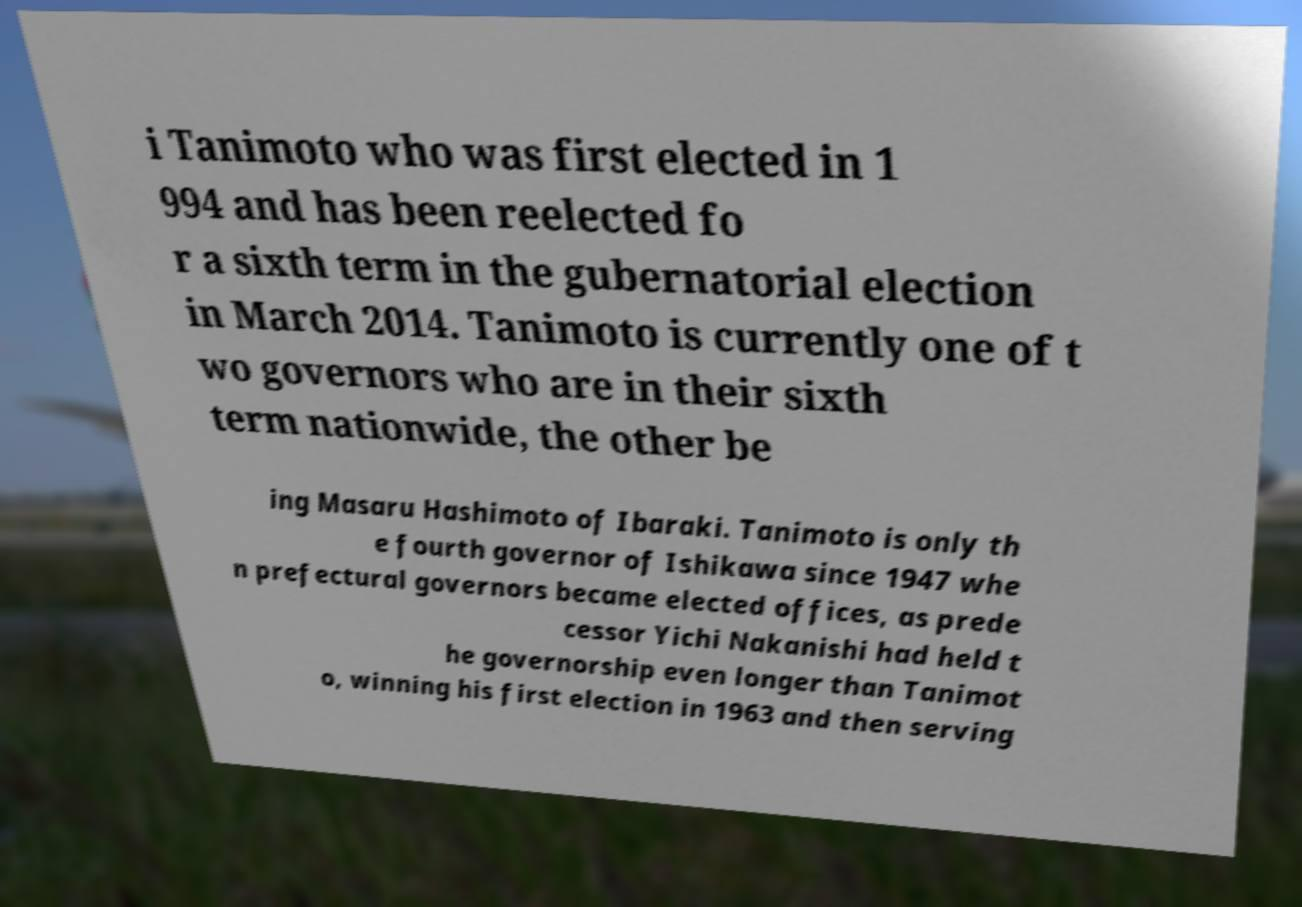I need the written content from this picture converted into text. Can you do that? i Tanimoto who was first elected in 1 994 and has been reelected fo r a sixth term in the gubernatorial election in March 2014. Tanimoto is currently one of t wo governors who are in their sixth term nationwide, the other be ing Masaru Hashimoto of Ibaraki. Tanimoto is only th e fourth governor of Ishikawa since 1947 whe n prefectural governors became elected offices, as prede cessor Yichi Nakanishi had held t he governorship even longer than Tanimot o, winning his first election in 1963 and then serving 